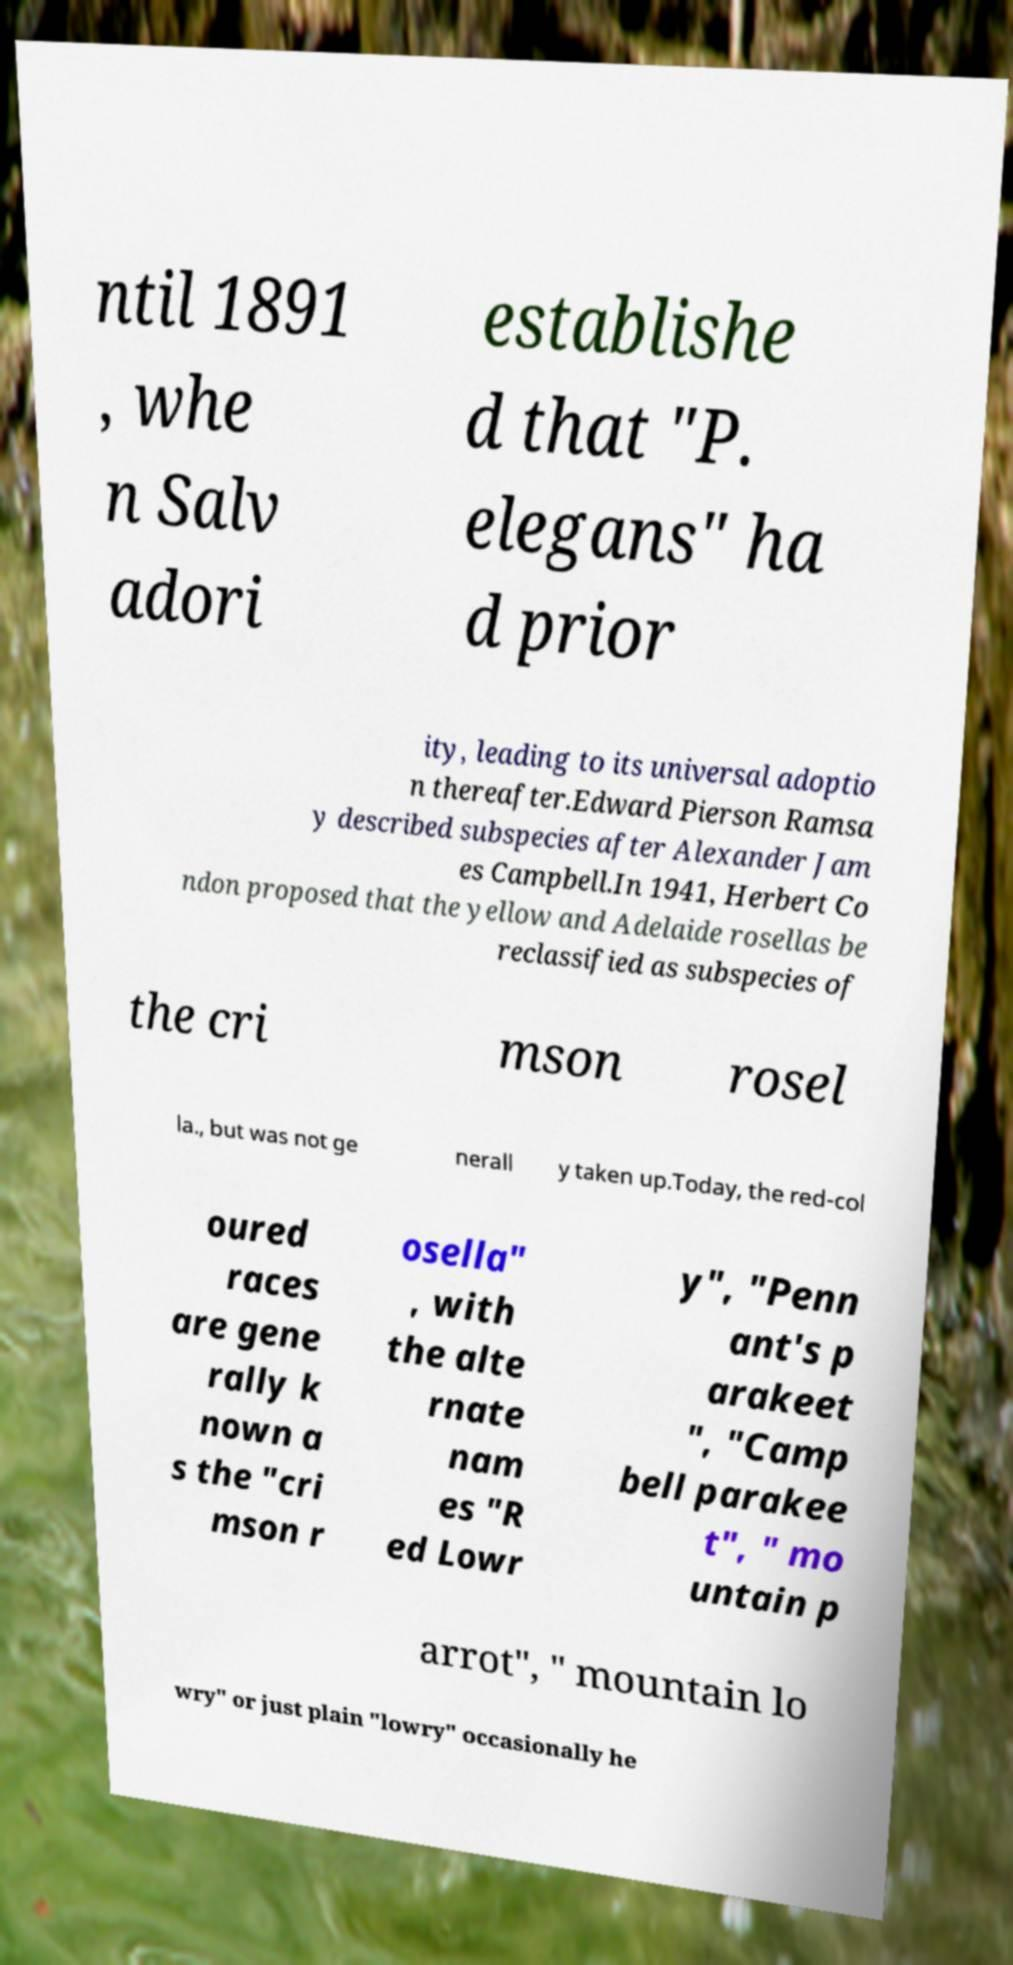Please identify and transcribe the text found in this image. ntil 1891 , whe n Salv adori establishe d that "P. elegans" ha d prior ity, leading to its universal adoptio n thereafter.Edward Pierson Ramsa y described subspecies after Alexander Jam es Campbell.In 1941, Herbert Co ndon proposed that the yellow and Adelaide rosellas be reclassified as subspecies of the cri mson rosel la., but was not ge nerall y taken up.Today, the red-col oured races are gene rally k nown a s the "cri mson r osella" , with the alte rnate nam es "R ed Lowr y", "Penn ant's p arakeet ", "Camp bell parakee t", " mo untain p arrot", " mountain lo wry" or just plain "lowry" occasionally he 